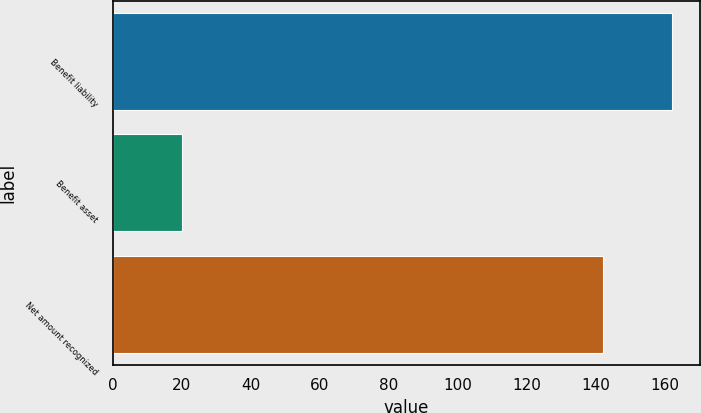Convert chart to OTSL. <chart><loc_0><loc_0><loc_500><loc_500><bar_chart><fcel>Benefit liability<fcel>Benefit asset<fcel>Net amount recognized<nl><fcel>162<fcel>20<fcel>142<nl></chart> 